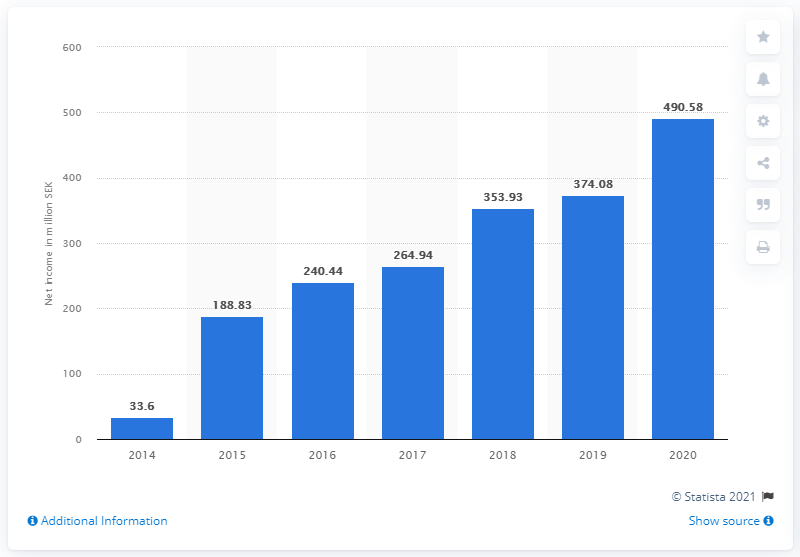Point out several critical features in this image. Paradox Interactive's net income in 2020 was 490.58 million. 